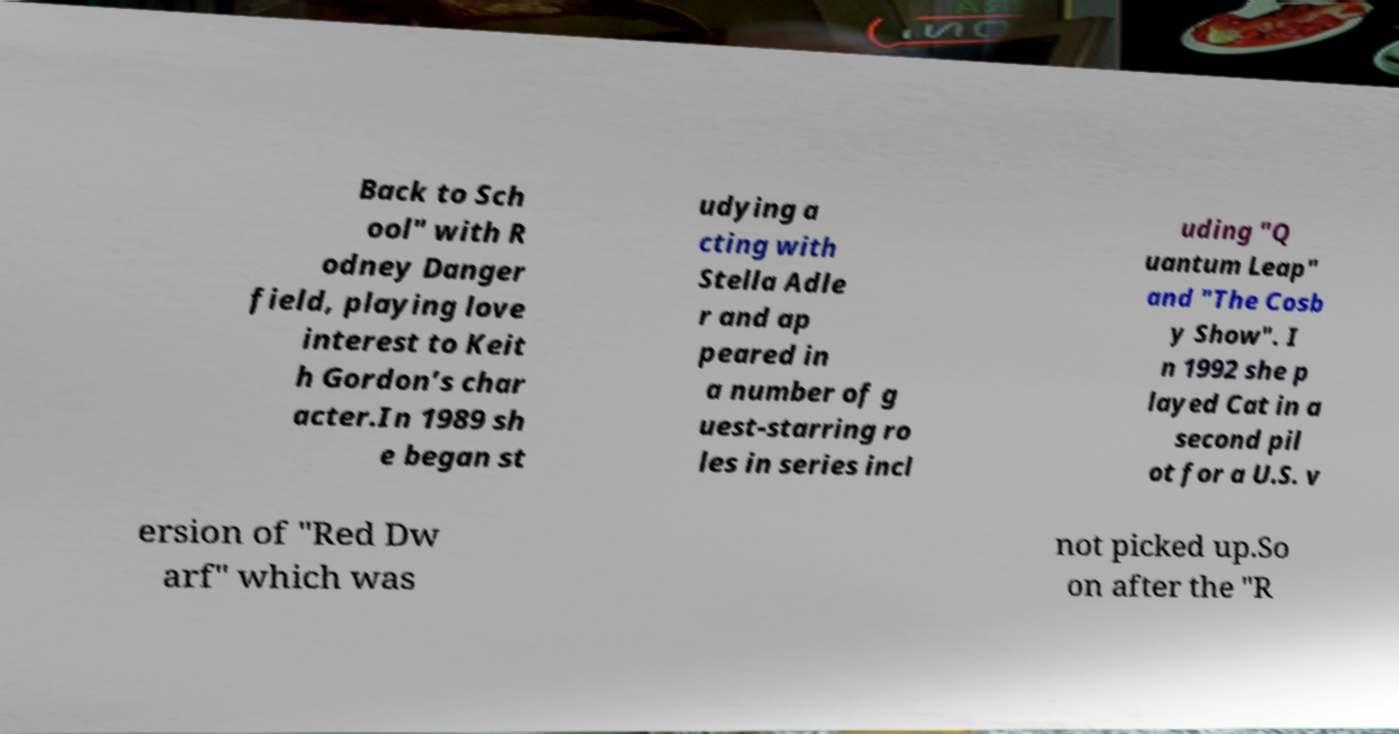Can you read and provide the text displayed in the image?This photo seems to have some interesting text. Can you extract and type it out for me? Back to Sch ool" with R odney Danger field, playing love interest to Keit h Gordon’s char acter.In 1989 sh e began st udying a cting with Stella Adle r and ap peared in a number of g uest-starring ro les in series incl uding "Q uantum Leap" and "The Cosb y Show". I n 1992 she p layed Cat in a second pil ot for a U.S. v ersion of "Red Dw arf" which was not picked up.So on after the "R 